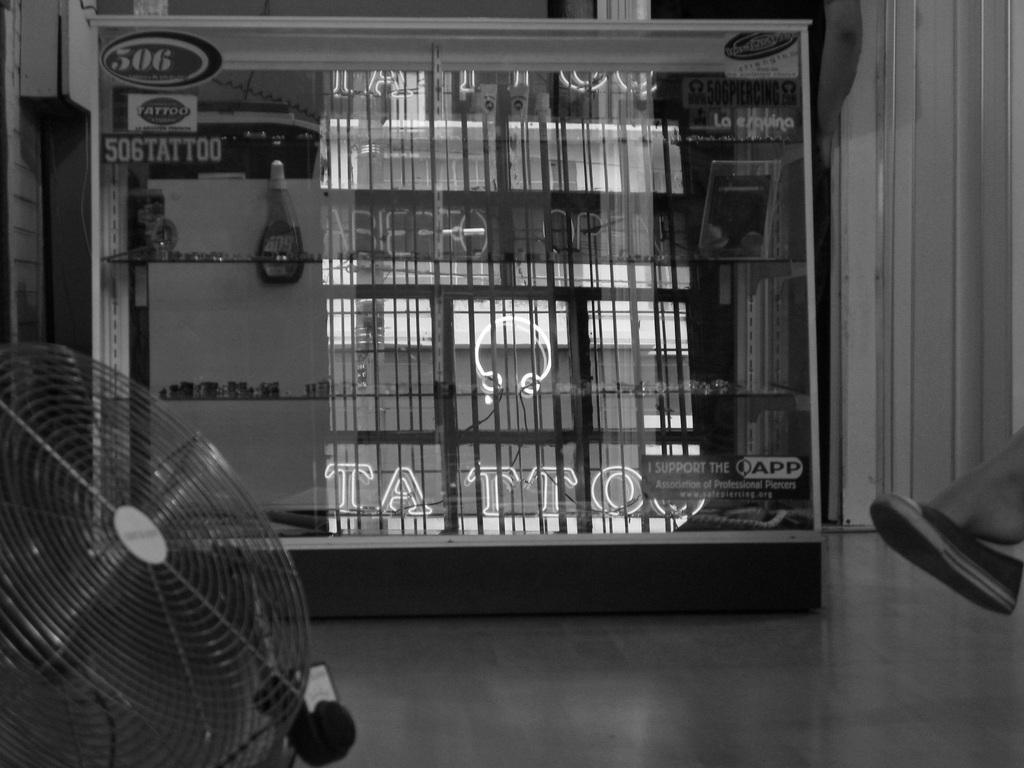Can you describe this image briefly? This is dan, there is shelf with objects in it. 